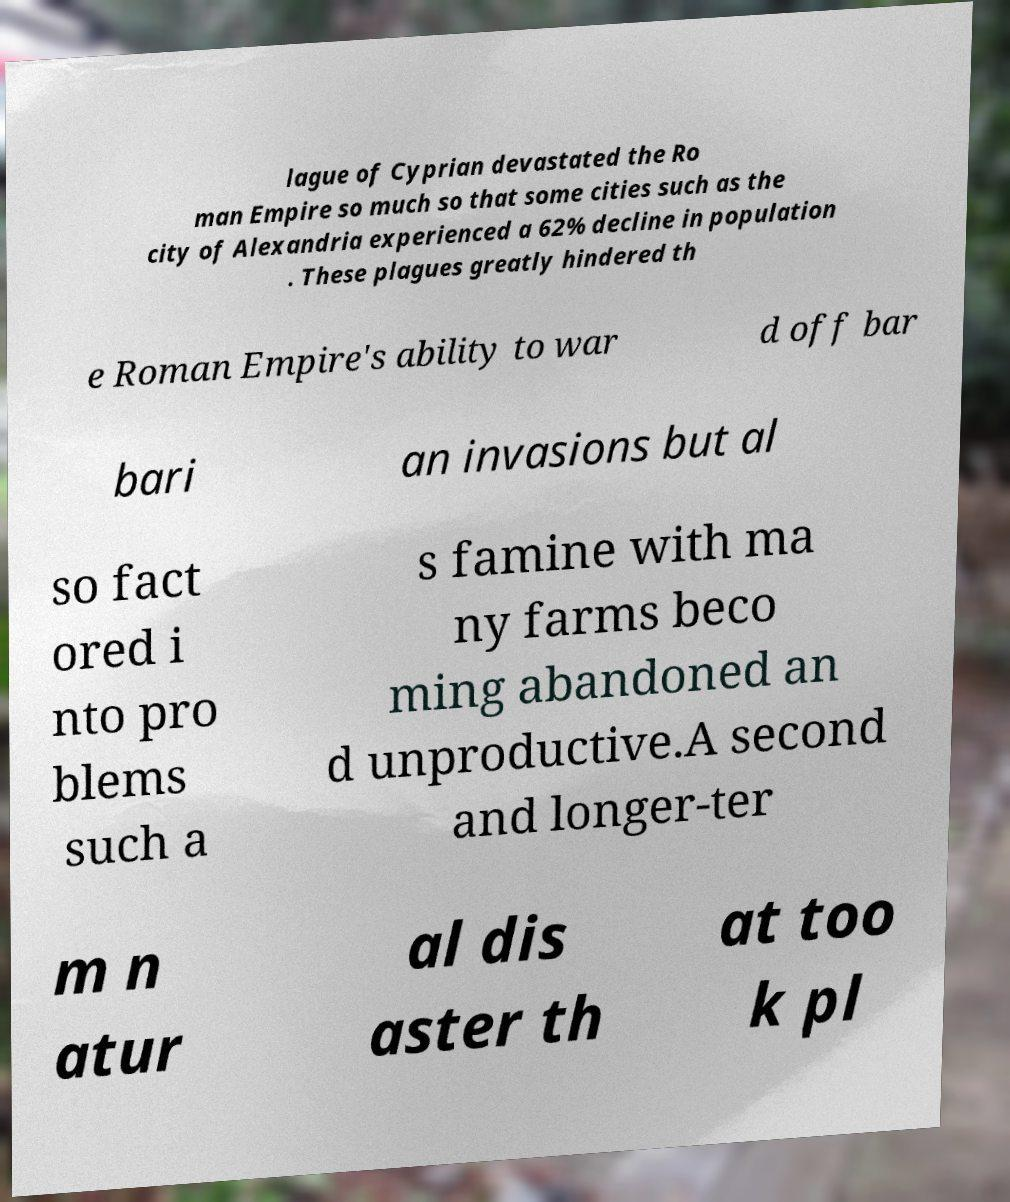What messages or text are displayed in this image? I need them in a readable, typed format. lague of Cyprian devastated the Ro man Empire so much so that some cities such as the city of Alexandria experienced a 62% decline in population . These plagues greatly hindered th e Roman Empire's ability to war d off bar bari an invasions but al so fact ored i nto pro blems such a s famine with ma ny farms beco ming abandoned an d unproductive.A second and longer-ter m n atur al dis aster th at too k pl 